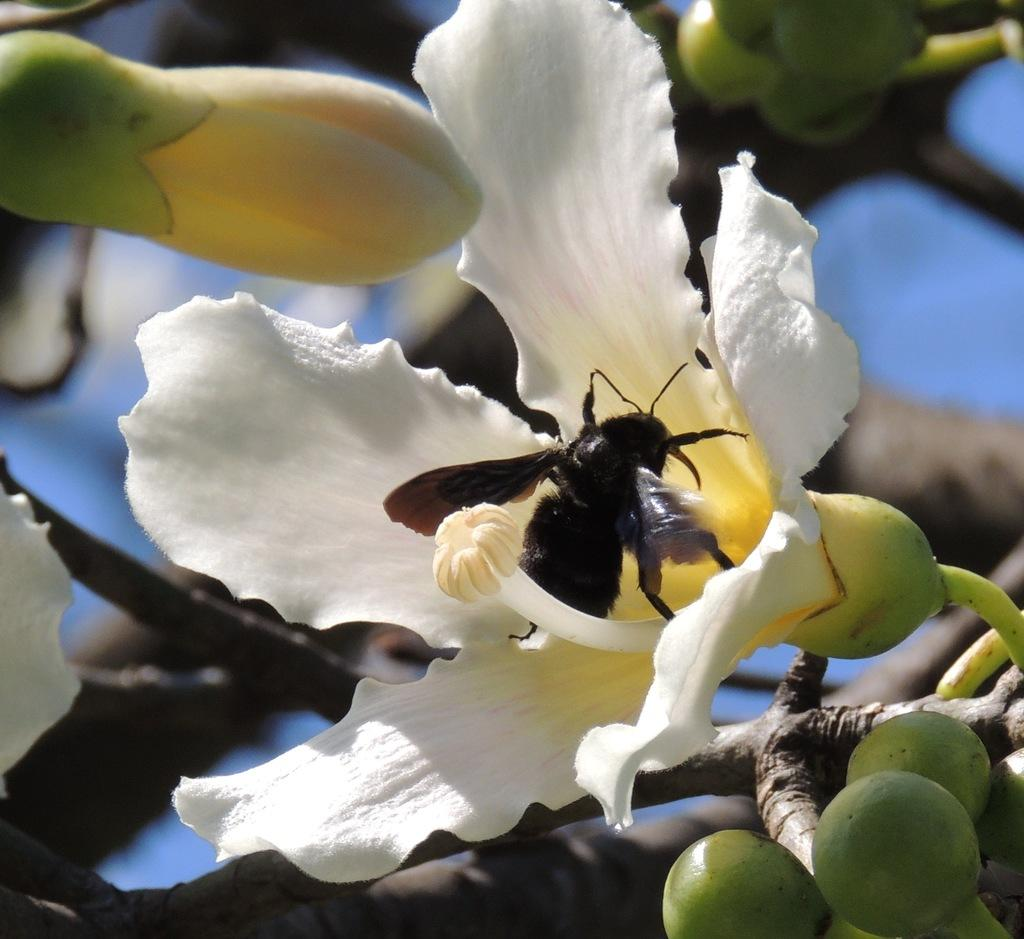What type of living organisms can be seen in the image? There are flowers and an insect in the image. Can you describe the insect in the image? Unfortunately, the provided facts do not give enough information to describe the insect in detail. What is the background of the image like? The background of the image is blurry. What type of shoe can be seen in the image? There is no shoe present in the image. Is there an alley visible in the image? There is no alley present in the image. 